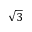<formula> <loc_0><loc_0><loc_500><loc_500>\sqrt { 3 }</formula> 